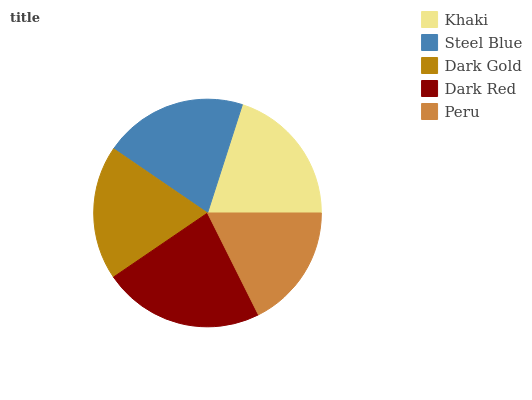Is Peru the minimum?
Answer yes or no. Yes. Is Dark Red the maximum?
Answer yes or no. Yes. Is Steel Blue the minimum?
Answer yes or no. No. Is Steel Blue the maximum?
Answer yes or no. No. Is Steel Blue greater than Khaki?
Answer yes or no. Yes. Is Khaki less than Steel Blue?
Answer yes or no. Yes. Is Khaki greater than Steel Blue?
Answer yes or no. No. Is Steel Blue less than Khaki?
Answer yes or no. No. Is Khaki the high median?
Answer yes or no. Yes. Is Khaki the low median?
Answer yes or no. Yes. Is Peru the high median?
Answer yes or no. No. Is Dark Gold the low median?
Answer yes or no. No. 